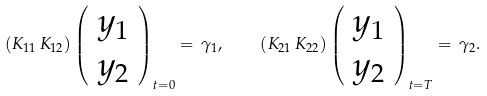<formula> <loc_0><loc_0><loc_500><loc_500>( K _ { 1 1 } \, K _ { 1 2 } ) \left ( \begin{array} { c } { y } _ { 1 } \\ { y } _ { 2 } \end{array} \right ) _ { t = 0 } = \, \gamma _ { 1 } , \quad ( K _ { 2 1 } \, K _ { 2 2 } ) \left ( \begin{array} { c } { y } _ { 1 } \\ { y } _ { 2 } \end{array} \right ) _ { t = T } = \, \gamma _ { 2 } .</formula> 